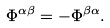<formula> <loc_0><loc_0><loc_500><loc_500>\Phi ^ { \alpha \beta } = - \Phi ^ { \beta \alpha } .</formula> 